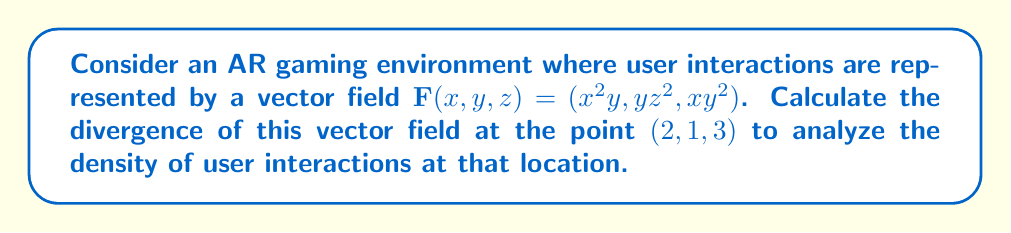Give your solution to this math problem. To solve this problem, we need to follow these steps:

1) The divergence of a vector field $\mathbf{F}(x,y,z) = (F_1, F_2, F_3)$ is given by:

   $$\text{div}\mathbf{F} = \nabla \cdot \mathbf{F} = \frac{\partial F_1}{\partial x} + \frac{\partial F_2}{\partial y} + \frac{\partial F_3}{\partial z}$$

2) For our vector field $\mathbf{F}(x,y,z) = (x^2y, yz^2, xy^2)$, we have:
   $F_1 = x^2y$
   $F_2 = yz^2$
   $F_3 = xy^2$

3) Now, let's calculate each partial derivative:

   $\frac{\partial F_1}{\partial x} = 2xy$
   
   $\frac{\partial F_2}{\partial y} = z^2$
   
   $\frac{\partial F_3}{\partial z} = 0$

4) The divergence is the sum of these partial derivatives:

   $$\text{div}\mathbf{F} = 2xy + z^2 + 0 = 2xy + z^2$$

5) To find the divergence at the point (2,1,3), we substitute these values:

   $$\text{div}\mathbf{F}(2,1,3) = 2(2)(1) + 3^2 = 4 + 9 = 13$$

This positive divergence indicates that there is a net outflow of user interactions at the point (2,1,3) in the AR environment, suggesting high user engagement at this location.
Answer: 13 